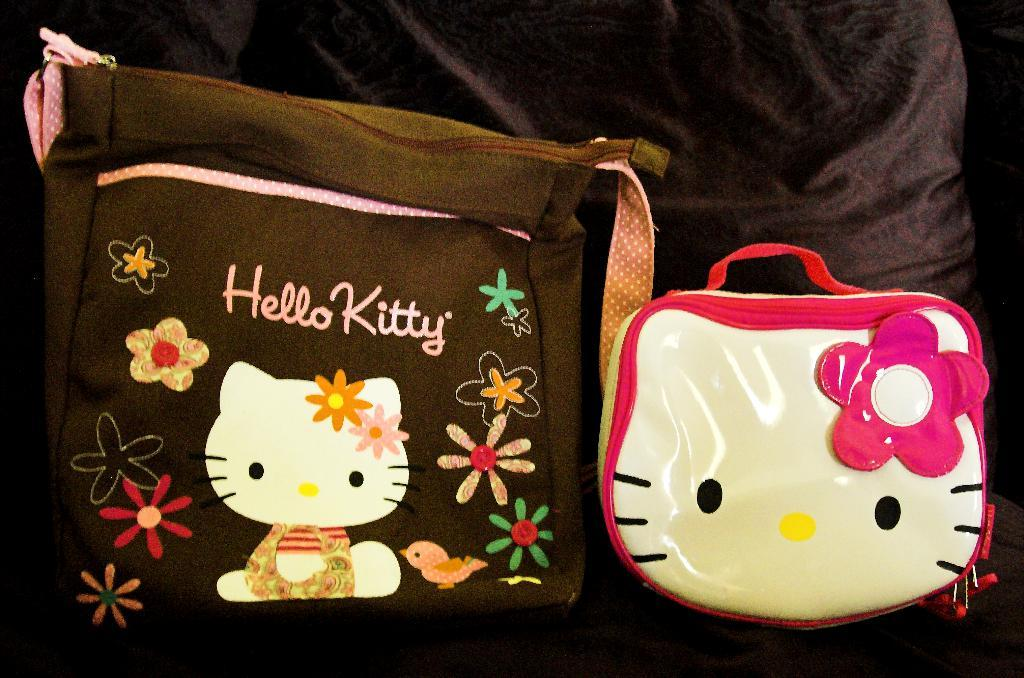What objects are visible in the image? There are bags in the image. Where are the bags placed? The bags are on a cloth. What can be found on the bags? There is text and some form of art on at least one bag. How many bikes are depicted on the page in the image? There is no page or bikes present in the image; it features bags on a cloth with text and art. 